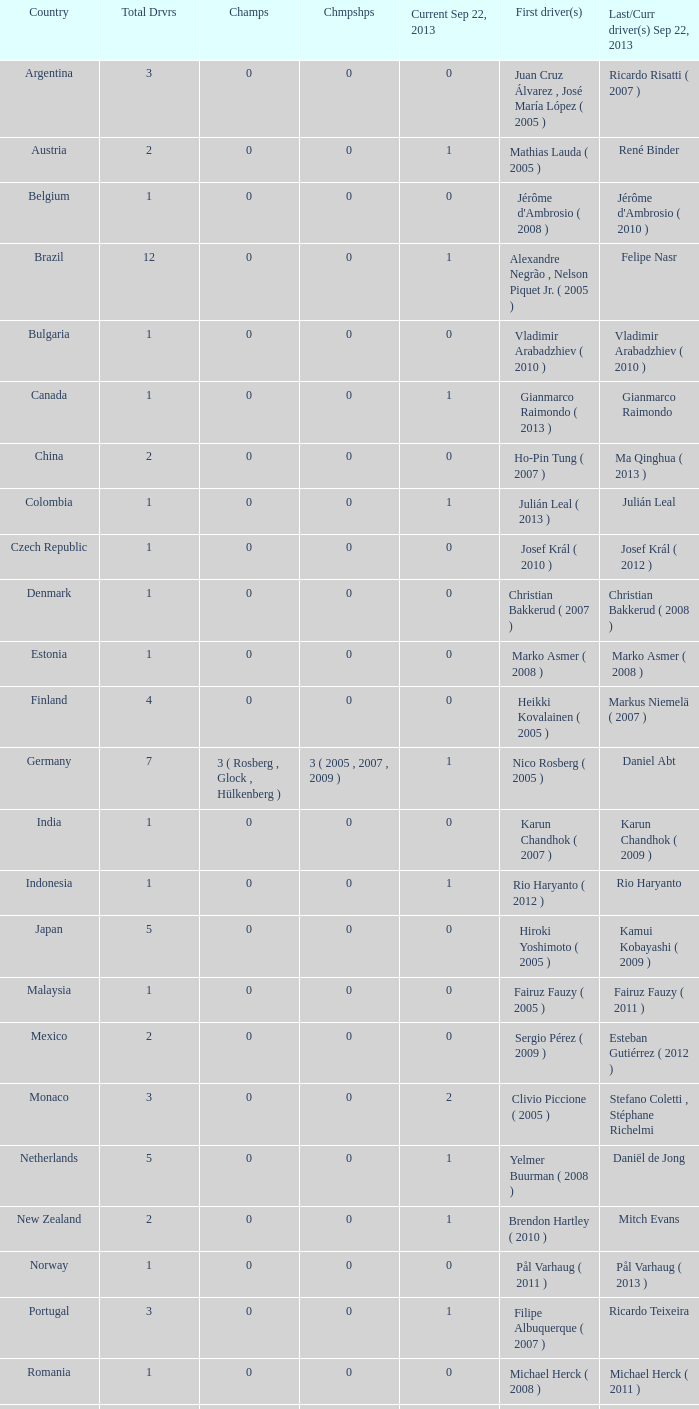How many entries are there for total drivers when the Last driver for september 22, 2013 was gianmarco raimondo? 1.0. 